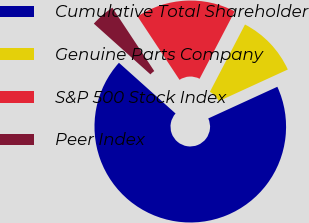Convert chart to OTSL. <chart><loc_0><loc_0><loc_500><loc_500><pie_chart><fcel>Cumulative Total Shareholder<fcel>Genuine Parts Company<fcel>S&P 500 Stock Index<fcel>Peer Index<nl><fcel>68.47%<fcel>10.51%<fcel>16.95%<fcel>4.07%<nl></chart> 